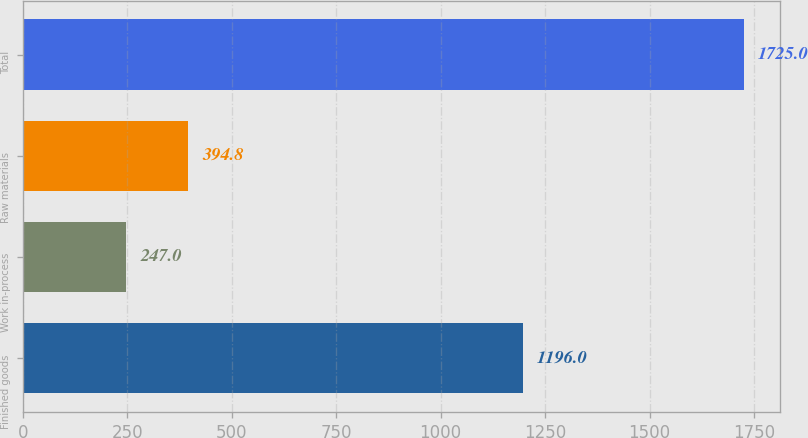Convert chart. <chart><loc_0><loc_0><loc_500><loc_500><bar_chart><fcel>Finished goods<fcel>Work in-process<fcel>Raw materials<fcel>Total<nl><fcel>1196<fcel>247<fcel>394.8<fcel>1725<nl></chart> 